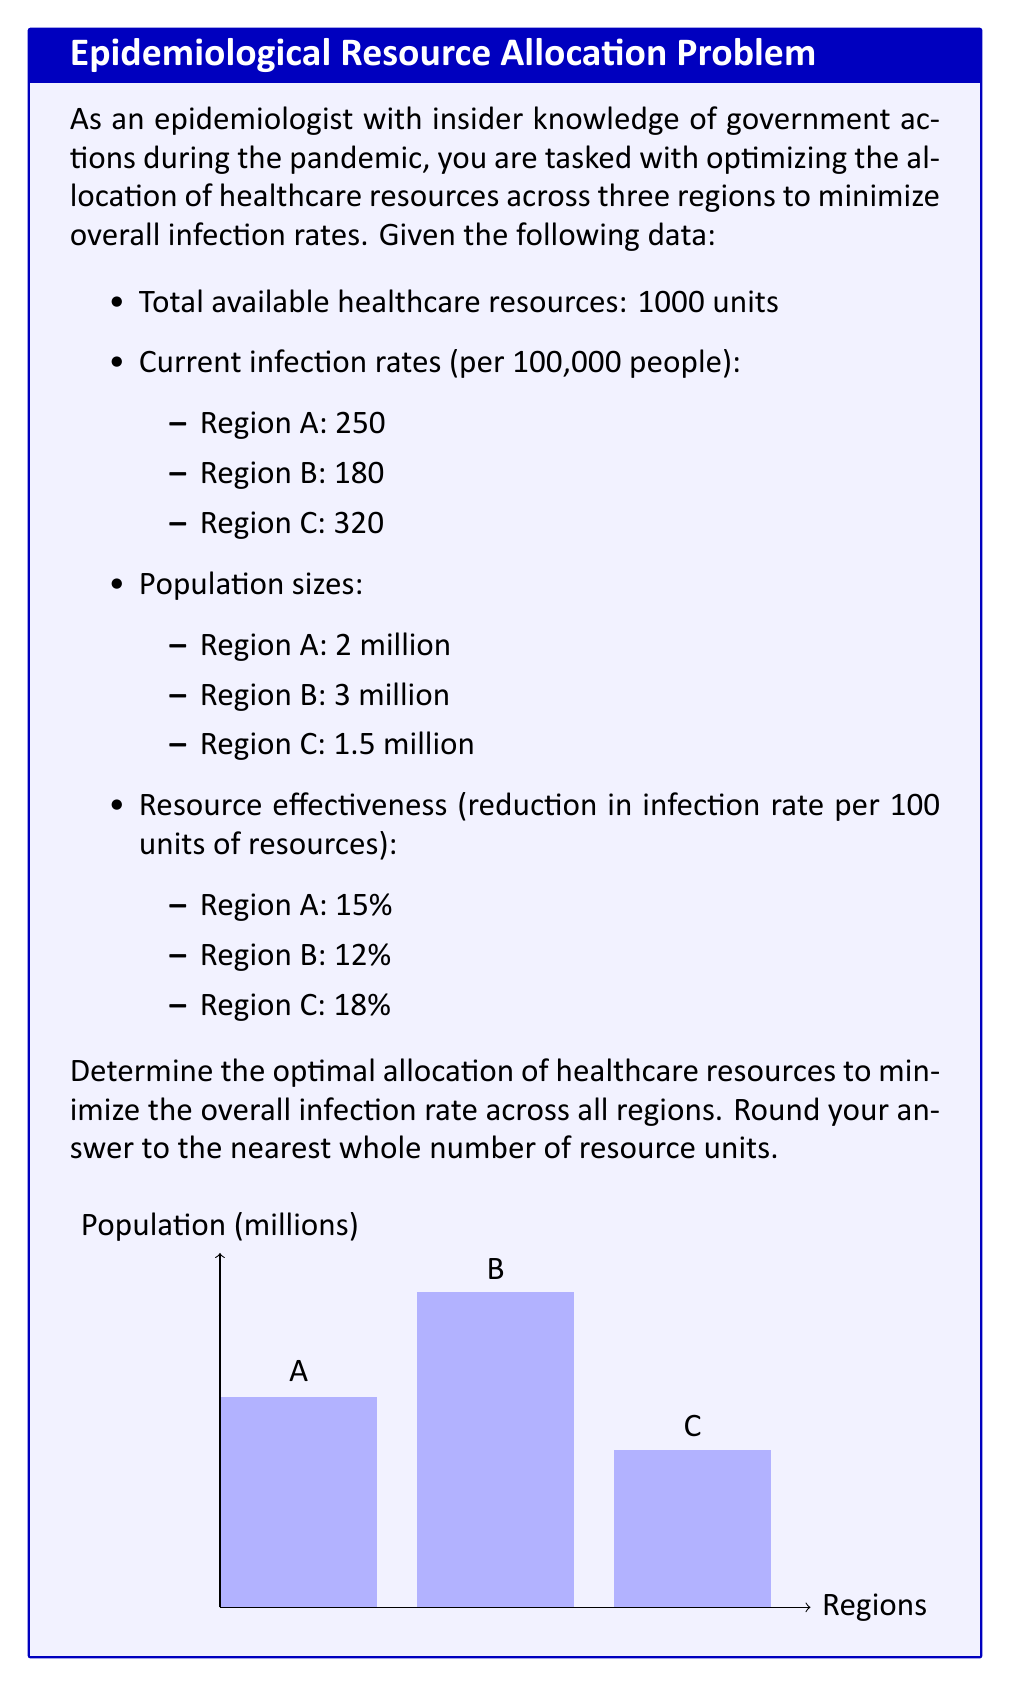Solve this math problem. To solve this optimization problem, we'll use the method of Lagrange multipliers. Let's follow these steps:

1) Define variables:
   Let $x_A$, $x_B$, and $x_C$ be the resources allocated to regions A, B, and C respectively.

2) Objective function:
   We want to minimize the overall infection rate, which is the weighted average of infection rates:
   $$f(x_A,x_B,x_C) = \frac{2(250(1-0.15x_A/100)) + 3(180(1-0.12x_B/100)) + 1.5(320(1-0.18x_C/100))}{6.5}$$

3) Constraint:
   The total resources must sum to 1000:
   $$g(x_A,x_B,x_C) = x_A + x_B + x_C - 1000 = 0$$

4) Lagrangian function:
   $$L(x_A,x_B,x_C,\lambda) = f(x_A,x_B,x_C) - \lambda g(x_A,x_B,x_C)$$

5) Partial derivatives:
   $$\frac{\partial L}{\partial x_A} = -\frac{2(250)(0.15)}{6.5(100)} - \lambda = 0$$
   $$\frac{\partial L}{\partial x_B} = -\frac{3(180)(0.12)}{6.5(100)} - \lambda = 0$$
   $$\frac{\partial L}{\partial x_C} = -\frac{1.5(320)(0.18)}{6.5(100)} - \lambda = 0$$
   $$\frac{\partial L}{\partial \lambda} = x_A + x_B + x_C - 1000 = 0$$

6) Solving the system of equations:
   From the first three equations, we can deduce:
   $$\frac{x_A}{2(250)(0.15)} = \frac{x_B}{3(180)(0.12)} = \frac{x_C}{1.5(320)(0.18)}$$

   Let's call this common ratio $k$. Then:
   $$x_A = 75k, x_B = 64.8k, x_C = 86.4k$$

   Substituting into the constraint equation:
   $$75k + 64.8k + 86.4k = 1000$$
   $$226.2k = 1000$$
   $$k = 4.42$$

7) Final allocation:
   $$x_A = 75(4.42) = 331.5$$
   $$x_B = 64.8(4.42) = 286.4$$
   $$x_C = 86.4(4.42) = 382.1$$

Rounding to the nearest whole number:
Region A: 332 units
Region B: 286 units
Region C: 382 units
Answer: A: 332, B: 286, C: 382 